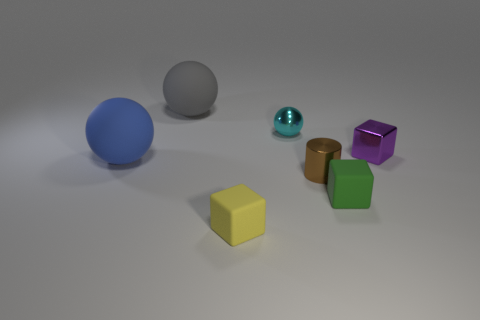Do the shiny block and the green rubber object have the same size?
Your answer should be compact. Yes. What is the color of the tiny rubber object that is in front of the tiny rubber cube behind the small cube that is left of the tiny sphere?
Provide a short and direct response. Yellow. How many spheres have the same color as the metal cube?
Provide a short and direct response. 0. What number of tiny things are brown objects or blue spheres?
Ensure brevity in your answer.  1. Are there any gray matte things of the same shape as the cyan shiny thing?
Give a very brief answer. Yes. Do the yellow matte thing and the gray rubber object have the same shape?
Your answer should be compact. No. There is a sphere to the right of the rubber object behind the tiny cyan shiny thing; what color is it?
Ensure brevity in your answer.  Cyan. What is the color of the other ball that is the same size as the gray matte sphere?
Ensure brevity in your answer.  Blue. What number of matte objects are tiny yellow objects or green blocks?
Your answer should be very brief. 2. What number of blue spheres are behind the matte ball that is right of the blue matte sphere?
Ensure brevity in your answer.  0. 